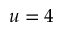Convert formula to latex. <formula><loc_0><loc_0><loc_500><loc_500>u = 4</formula> 